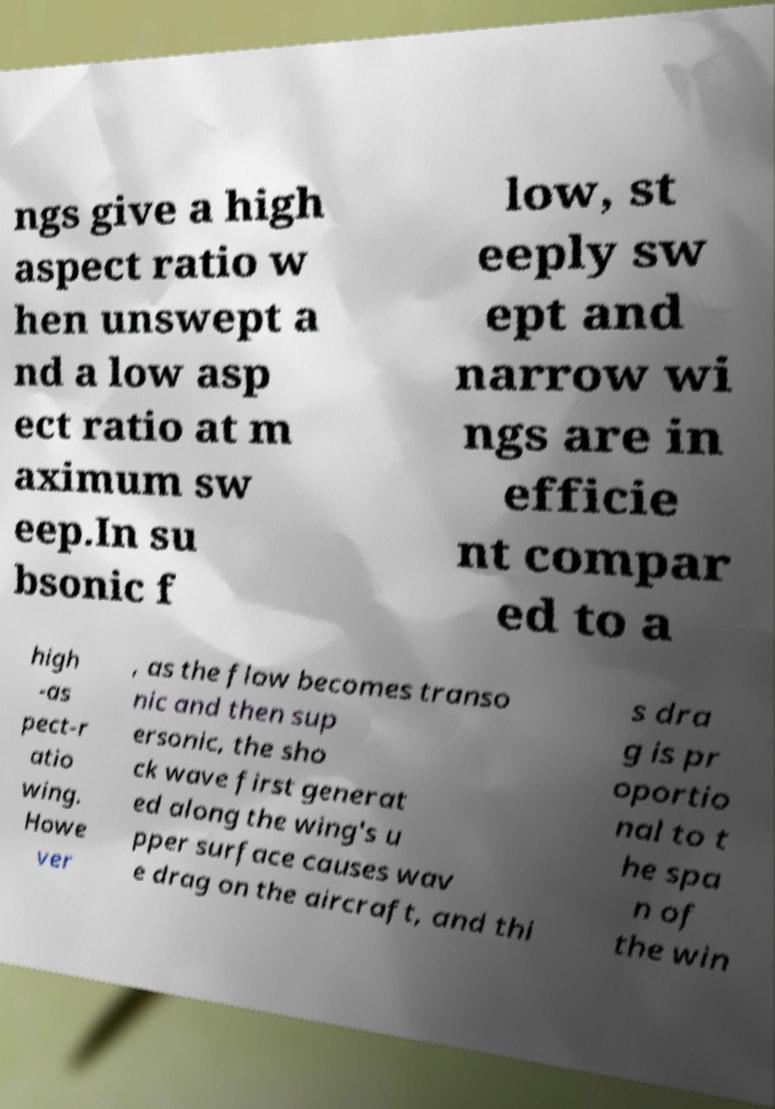Please read and relay the text visible in this image. What does it say? ngs give a high aspect ratio w hen unswept a nd a low asp ect ratio at m aximum sw eep.In su bsonic f low, st eeply sw ept and narrow wi ngs are in efficie nt compar ed to a high -as pect-r atio wing. Howe ver , as the flow becomes transo nic and then sup ersonic, the sho ck wave first generat ed along the wing's u pper surface causes wav e drag on the aircraft, and thi s dra g is pr oportio nal to t he spa n of the win 